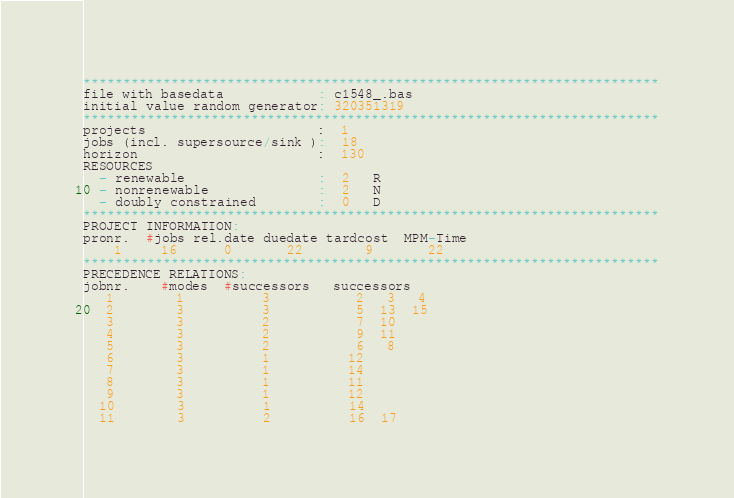Convert code to text. <code><loc_0><loc_0><loc_500><loc_500><_ObjectiveC_>************************************************************************
file with basedata            : c1548_.bas
initial value random generator: 320351319
************************************************************************
projects                      :  1
jobs (incl. supersource/sink ):  18
horizon                       :  130
RESOURCES
  - renewable                 :  2   R
  - nonrenewable              :  2   N
  - doubly constrained        :  0   D
************************************************************************
PROJECT INFORMATION:
pronr.  #jobs rel.date duedate tardcost  MPM-Time
    1     16      0       22        9       22
************************************************************************
PRECEDENCE RELATIONS:
jobnr.    #modes  #successors   successors
   1        1          3           2   3   4
   2        3          3           5  13  15
   3        3          2           7  10
   4        3          2           9  11
   5        3          2           6   8
   6        3          1          12
   7        3          1          14
   8        3          1          11
   9        3          1          12
  10        3          1          14
  11        3          2          16  17</code> 